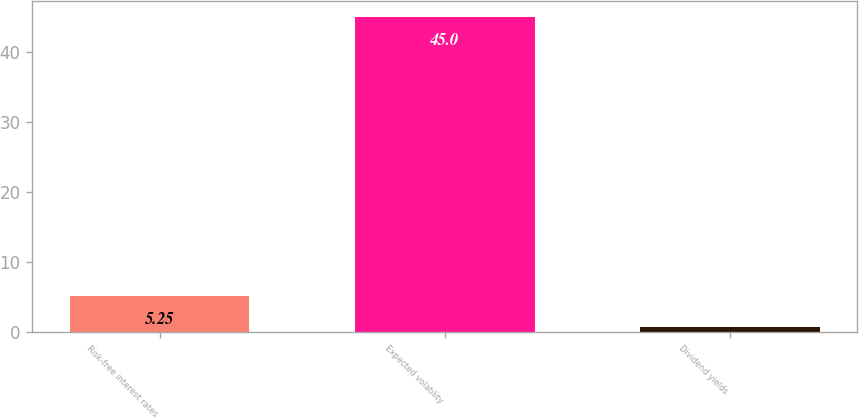Convert chart to OTSL. <chart><loc_0><loc_0><loc_500><loc_500><bar_chart><fcel>Risk-free interest rates<fcel>Expected volatility<fcel>Dividend yields<nl><fcel>5.25<fcel>45<fcel>0.83<nl></chart> 